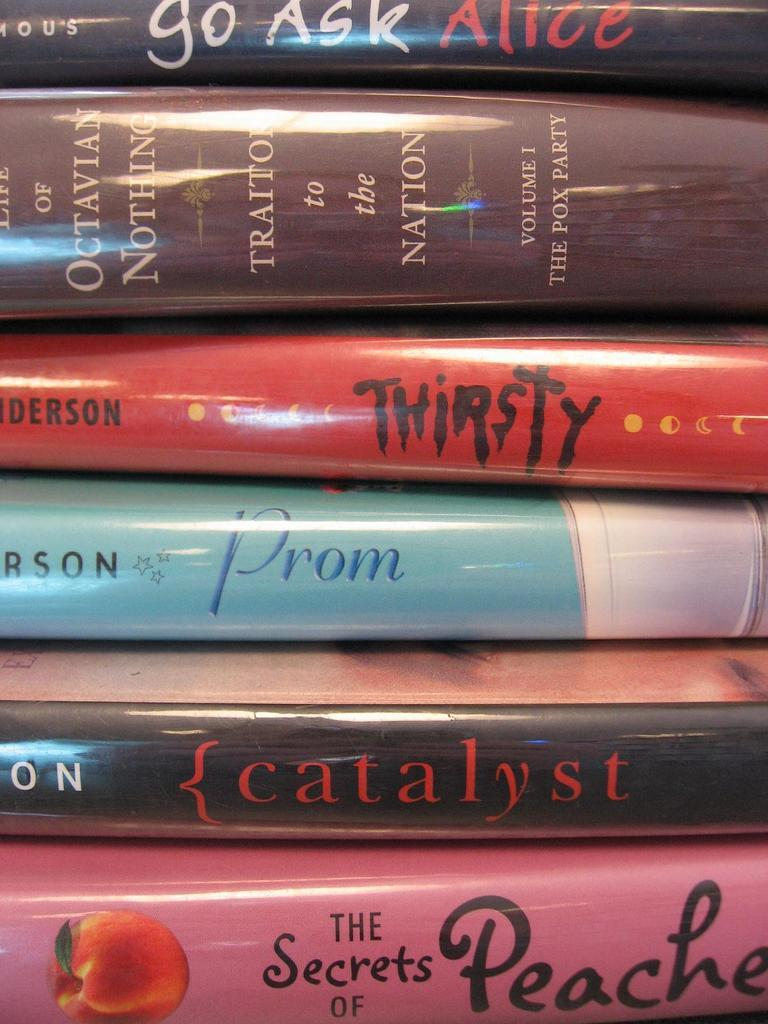<image>
Relay a brief, clear account of the picture shown. Many books are stacked on top of one another with Go ask Alice on the top 